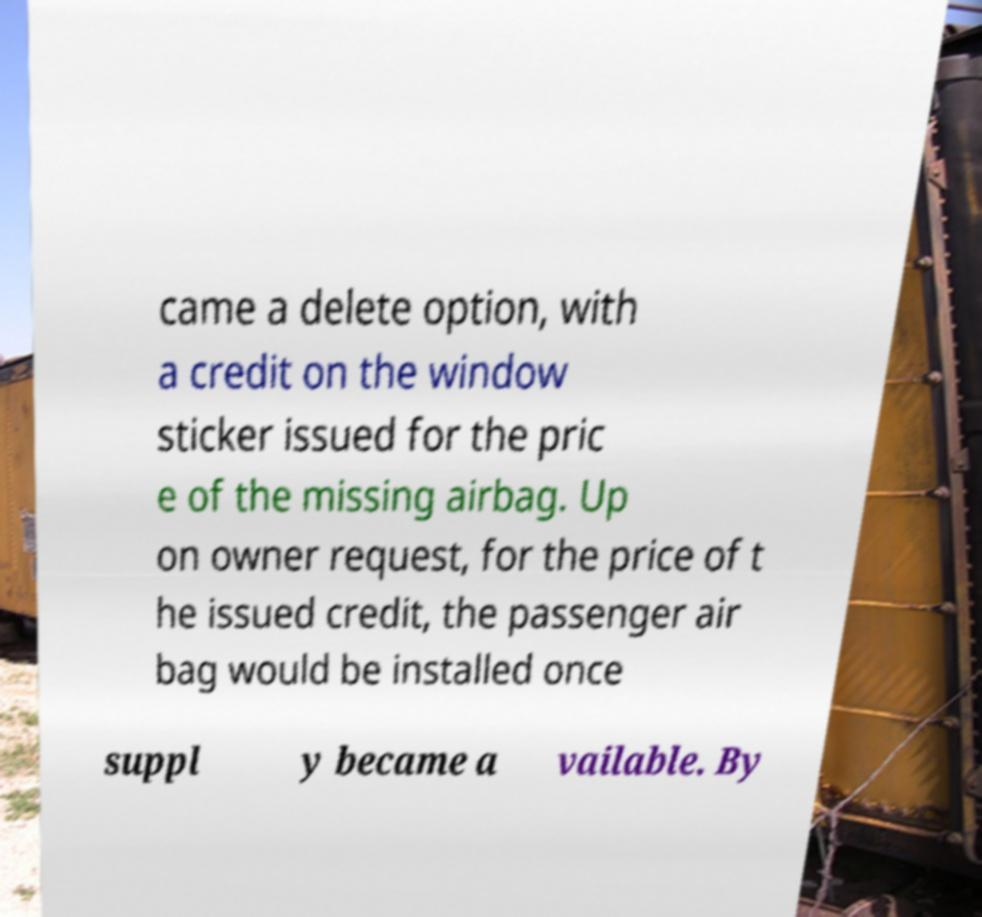Could you extract and type out the text from this image? came a delete option, with a credit on the window sticker issued for the pric e of the missing airbag. Up on owner request, for the price of t he issued credit, the passenger air bag would be installed once suppl y became a vailable. By 